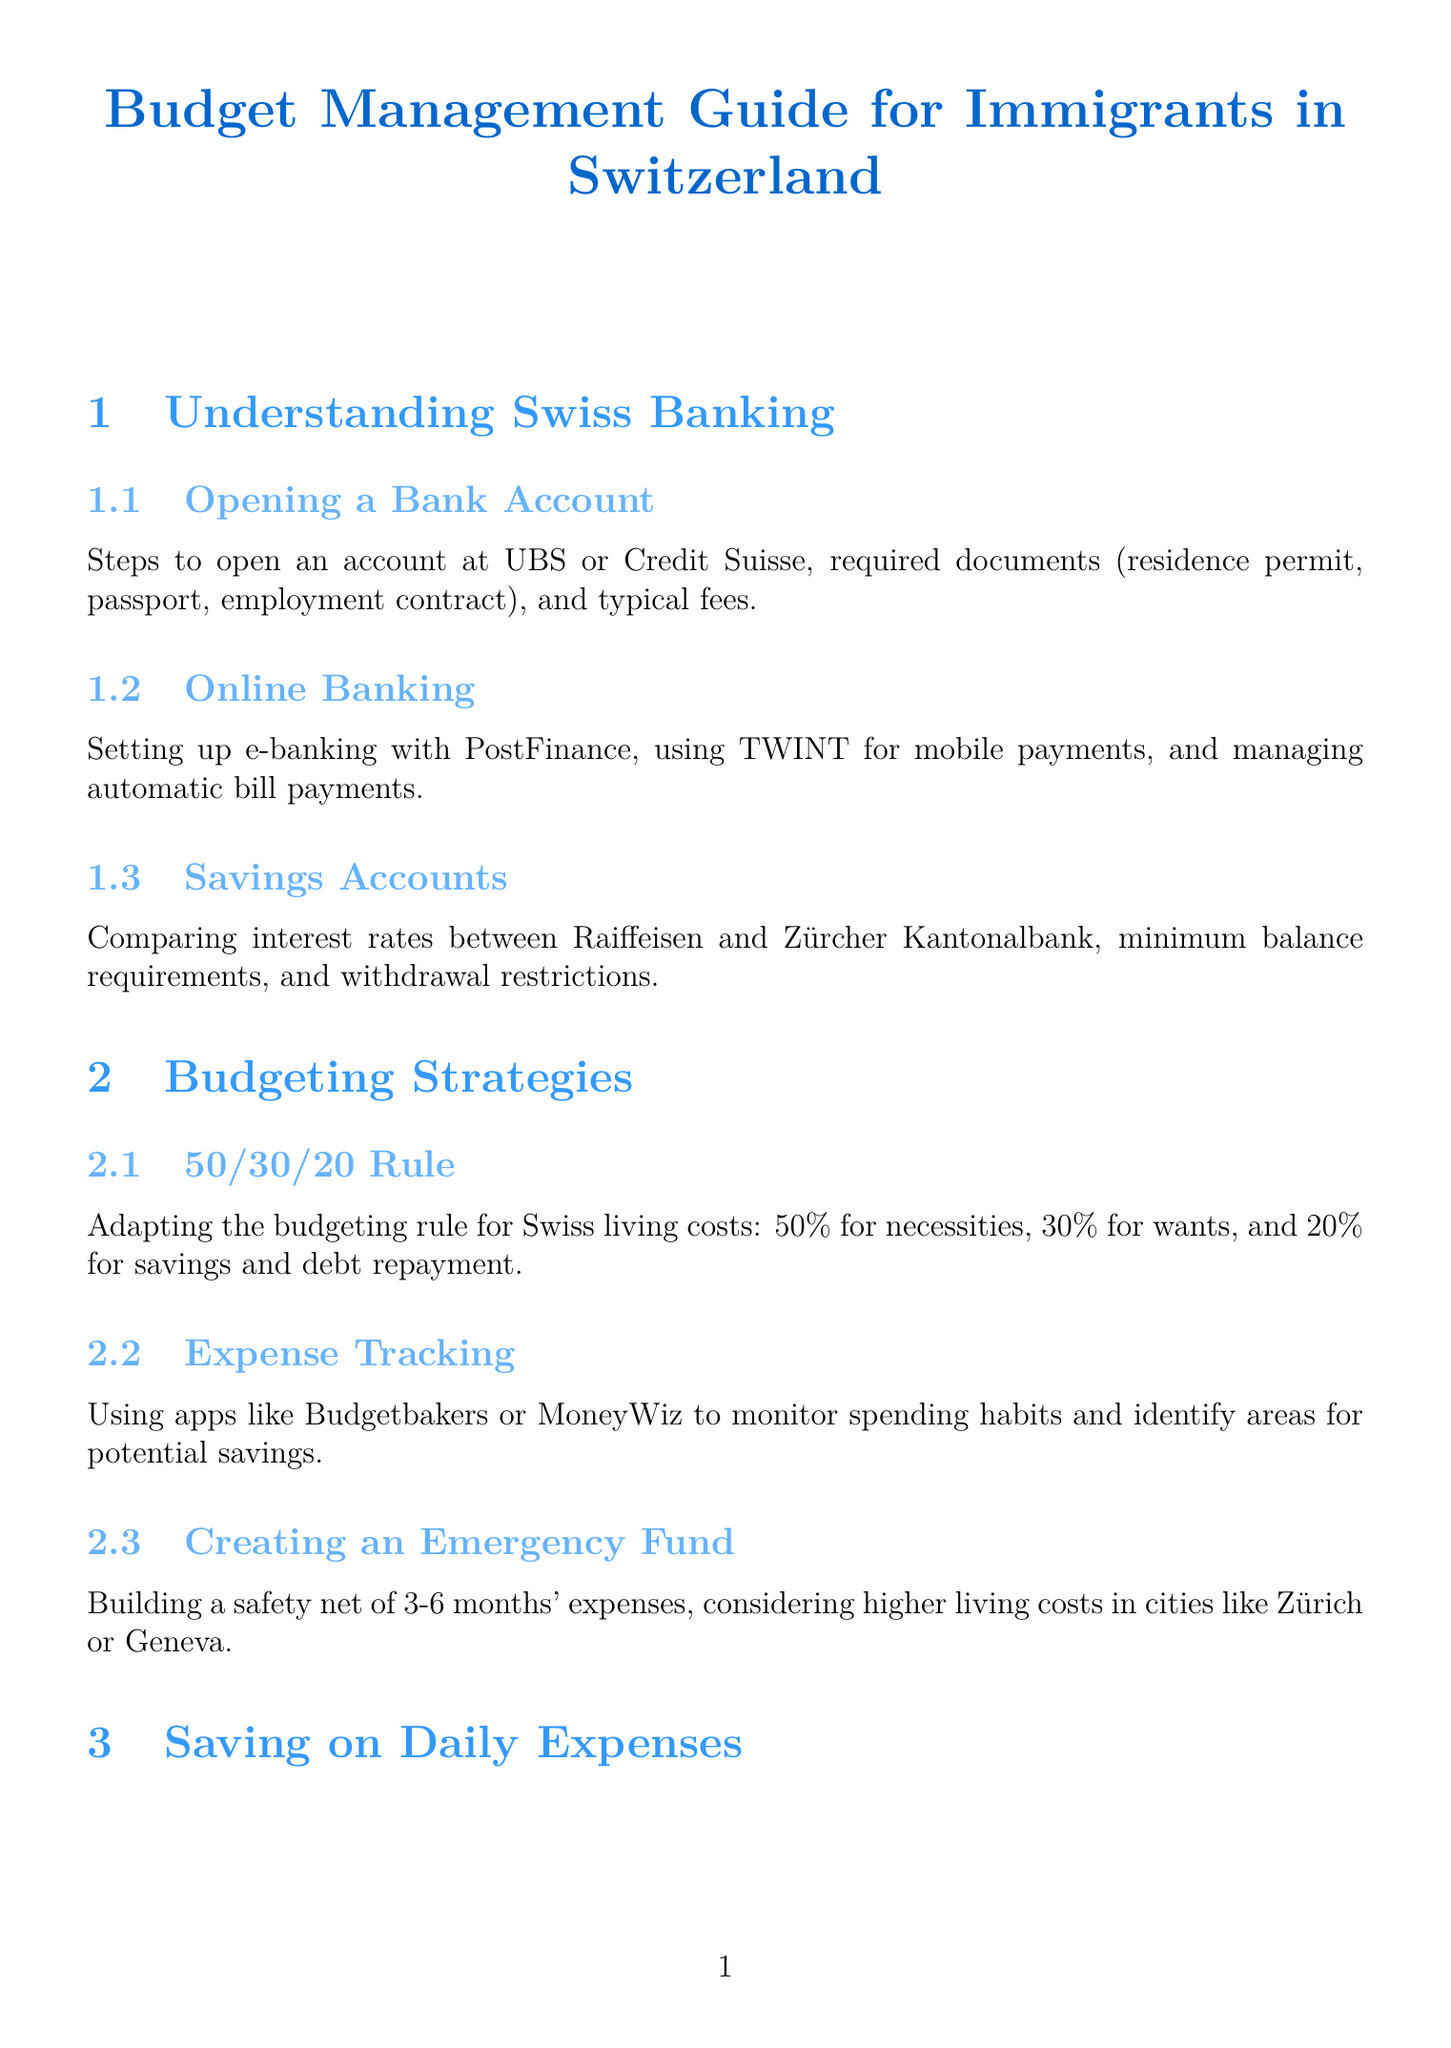What documents are required to open a bank account? The document lists the required documents needed for opening a bank account at UBS or Credit Suisse.
Answer: residence permit, passport, employment contract What is the 50/30/20 rule? The document explains this budgeting rule tailored for Swiss living costs.
Answer: 50% for necessities, 30% for wants, and 20% for savings and debt repayment Which apps can be used for expense tracking? The document provides two examples of apps suitable for monitoring spending habits.
Answer: Budgetbakers or MoneyWiz What program is used for SBB train discounts? The document mentions a specific discount travel card for trains.
Answer: Half-Fare travelcard What is the three-pillar system related to? The document refers to a financial concept that includes different pension options in Switzerland.
Answer: Pension System What type of assistance does RAV provide? The document indicates the type of support provided by Regional Employment Centers.
Answer: job search assistance and vocational training Where can you find affordable housing options? The document suggests specific websites to help locate affordable accommodations.
Answer: Homegate and Comparis What is a common strategy to build savings? The document outlines a financial strategy for creating a safety net.
Answer: Creating an Emergency Fund Who can access discounts with the KulturLegi card? The document explains what the KulturLegi card is used for.
Answer: discounts on museums, theaters, and sports facilities 